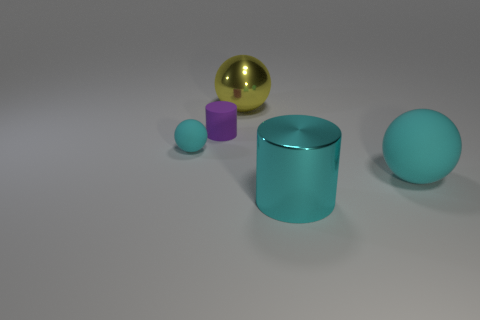Add 3 tiny red matte blocks. How many objects exist? 8 Subtract all balls. How many objects are left? 2 Subtract all large balls. Subtract all yellow metal things. How many objects are left? 2 Add 4 balls. How many balls are left? 7 Add 1 matte spheres. How many matte spheres exist? 3 Subtract 0 gray cylinders. How many objects are left? 5 